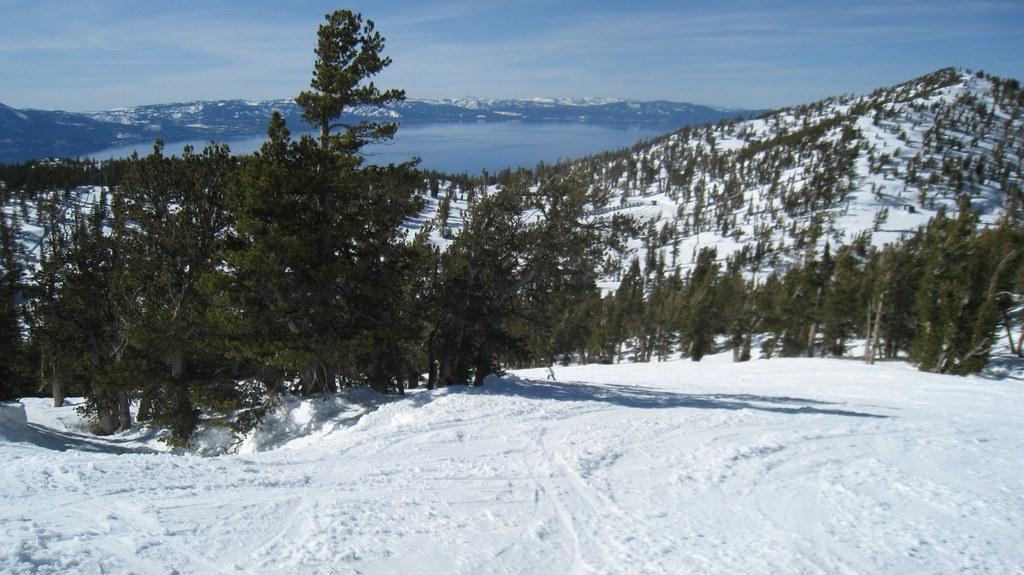Please provide a concise description of this image. This picture shows trees and we see a water and a blue cloudy sky and we see snow. 